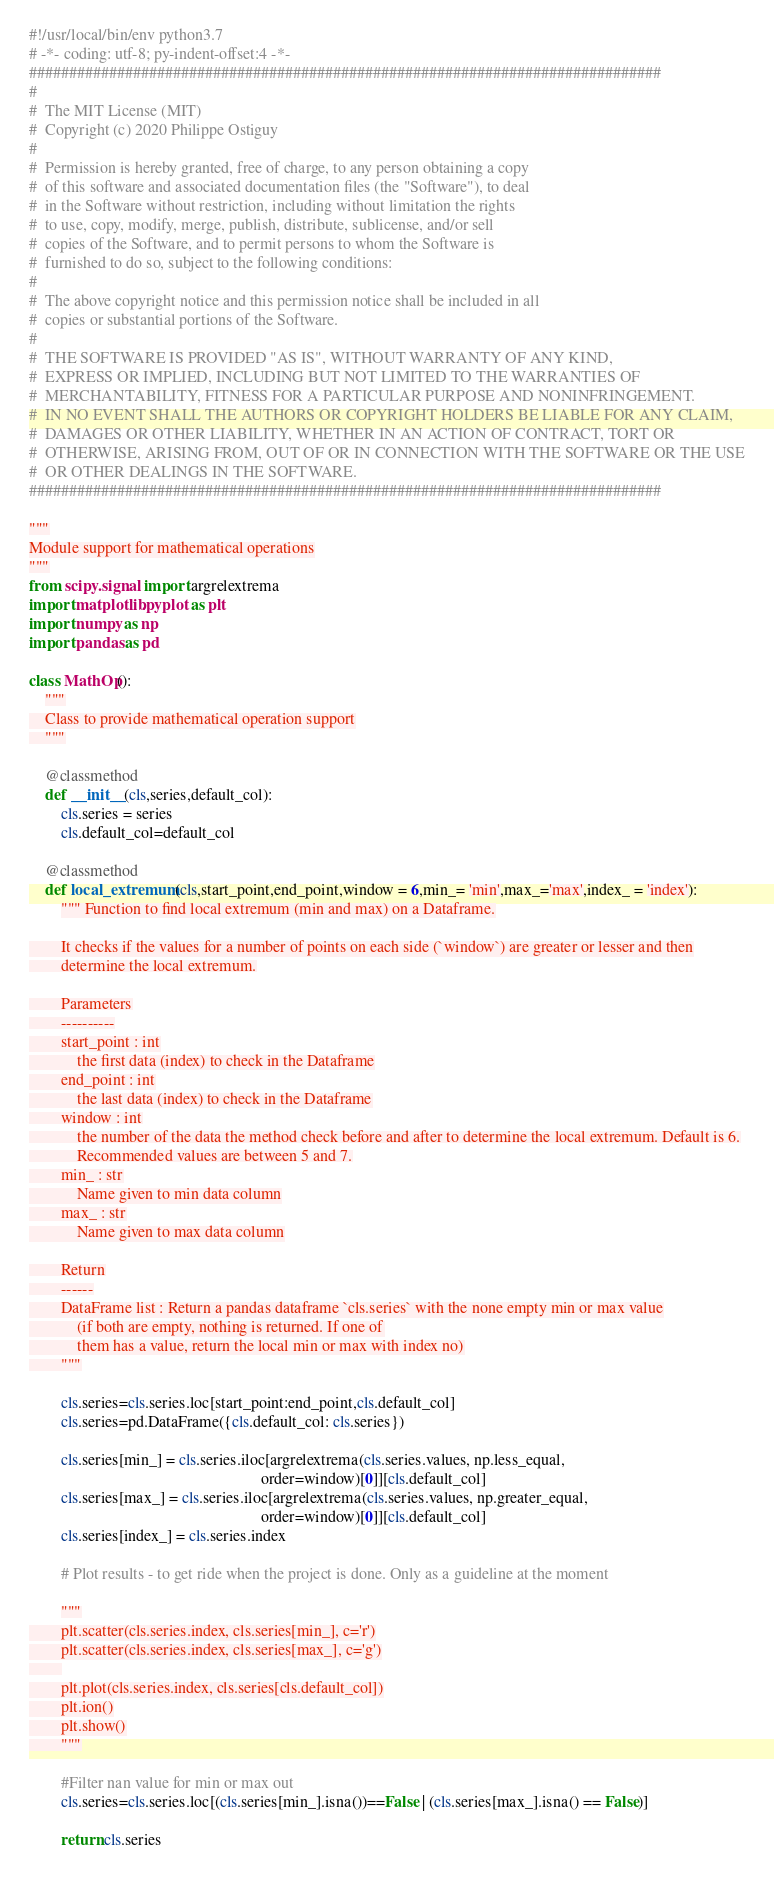<code> <loc_0><loc_0><loc_500><loc_500><_Python_>#!/usr/local/bin/env python3.7
# -*- coding: utf-8; py-indent-offset:4 -*-
###############################################################################
#
#  The MIT License (MIT)
#  Copyright (c) 2020 Philippe Ostiguy
#
#  Permission is hereby granted, free of charge, to any person obtaining a copy
#  of this software and associated documentation files (the "Software"), to deal
#  in the Software without restriction, including without limitation the rights
#  to use, copy, modify, merge, publish, distribute, sublicense, and/or sell
#  copies of the Software, and to permit persons to whom the Software is
#  furnished to do so, subject to the following conditions:
#
#  The above copyright notice and this permission notice shall be included in all
#  copies or substantial portions of the Software.
#
#  THE SOFTWARE IS PROVIDED "AS IS", WITHOUT WARRANTY OF ANY KIND,
#  EXPRESS OR IMPLIED, INCLUDING BUT NOT LIMITED TO THE WARRANTIES OF
#  MERCHANTABILITY, FITNESS FOR A PARTICULAR PURPOSE AND NONINFRINGEMENT.
#  IN NO EVENT SHALL THE AUTHORS OR COPYRIGHT HOLDERS BE LIABLE FOR ANY CLAIM,
#  DAMAGES OR OTHER LIABILITY, WHETHER IN AN ACTION OF CONTRACT, TORT OR
#  OTHERWISE, ARISING FROM, OUT OF OR IN CONNECTION WITH THE SOFTWARE OR THE USE
#  OR OTHER DEALINGS IN THE SOFTWARE.
###############################################################################

"""
Module support for mathematical operations
"""
from scipy.signal import argrelextrema
import matplotlib.pyplot as plt
import numpy as np
import pandas as pd

class MathOp():
    """
    Class to provide mathematical operation support
    """

    @classmethod
    def __init__(cls,series,default_col):
        cls.series = series
        cls.default_col=default_col

    @classmethod
    def local_extremum(cls,start_point,end_point,window = 6,min_= 'min',max_='max',index_ = 'index'):
        """ Function to find local extremum (min and max) on a Dataframe.

        It checks if the values for a number of points on each side (`window`) are greater or lesser and then
        determine the local extremum.

        Parameters
        ----------
        start_point : int
            the first data (index) to check in the Dataframe
        end_point : int
            the last data (index) to check in the Dataframe
        window : int
            the number of the data the method check before and after to determine the local extremum. Default is 6.
            Recommended values are between 5 and 7.
        min_ : str
            Name given to min data column
        max_ : str
            Name given to max data column

        Return
        ------
        DataFrame list : Return a pandas dataframe `cls.series` with the none empty min or max value
            (if both are empty, nothing is returned. If one of
            them has a value, return the local min or max with index no)
        """

        cls.series=cls.series.loc[start_point:end_point,cls.default_col]
        cls.series=pd.DataFrame({cls.default_col: cls.series})

        cls.series[min_] = cls.series.iloc[argrelextrema(cls.series.values, np.less_equal,
                                                          order=window)[0]][cls.default_col]
        cls.series[max_] = cls.series.iloc[argrelextrema(cls.series.values, np.greater_equal,
                                                          order=window)[0]][cls.default_col]
        cls.series[index_] = cls.series.index

        # Plot results - to get ride when the project is done. Only as a guideline at the moment

        """
        plt.scatter(cls.series.index, cls.series[min_], c='r')
        plt.scatter(cls.series.index, cls.series[max_], c='g')
        
        plt.plot(cls.series.index, cls.series[cls.default_col])
        plt.ion()
        plt.show()
        """

        #Filter nan value for min or max out
        cls.series=cls.series.loc[(cls.series[min_].isna())==False | (cls.series[max_].isna() == False)]

        return cls.series</code> 